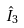<formula> <loc_0><loc_0><loc_500><loc_500>\hat { I } _ { 3 }</formula> 